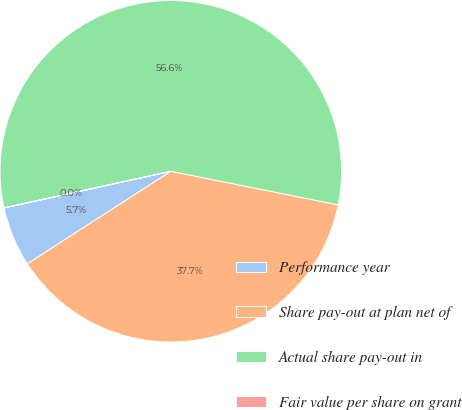Convert chart. <chart><loc_0><loc_0><loc_500><loc_500><pie_chart><fcel>Performance year<fcel>Share pay-out at plan net of<fcel>Actual share pay-out in<fcel>Fair value per share on grant<nl><fcel>5.67%<fcel>37.73%<fcel>56.59%<fcel>0.01%<nl></chart> 